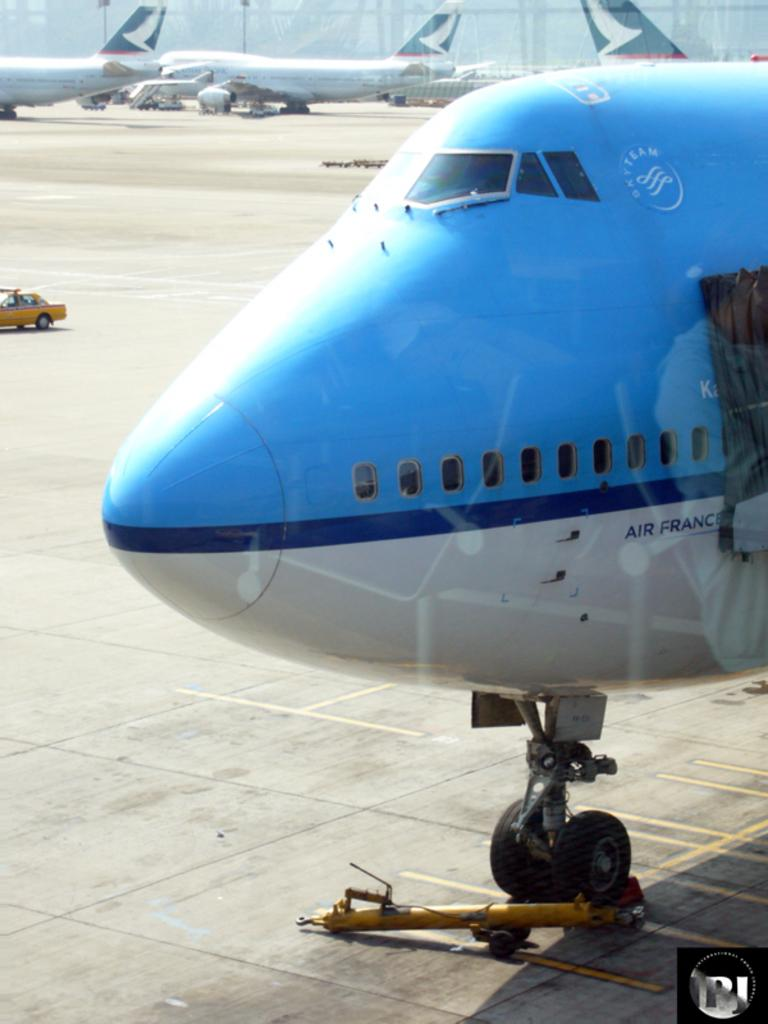What color is the aircraft in the image? The aircraft in the image is white and blue. Where is the aircraft located? The aircraft is parked on the runway. How many other aircraft can be seen behind the first one? There are three more aircraft parked behind the first one. What is visible in the background of the image? There is a big boundary wall in the background of the image. Can you see any rabbits hopping around the aircraft in the image? No, there are no rabbits present in the image. Is there a crook standing near the aircraft in the image? No, there is no crook present in the image. 